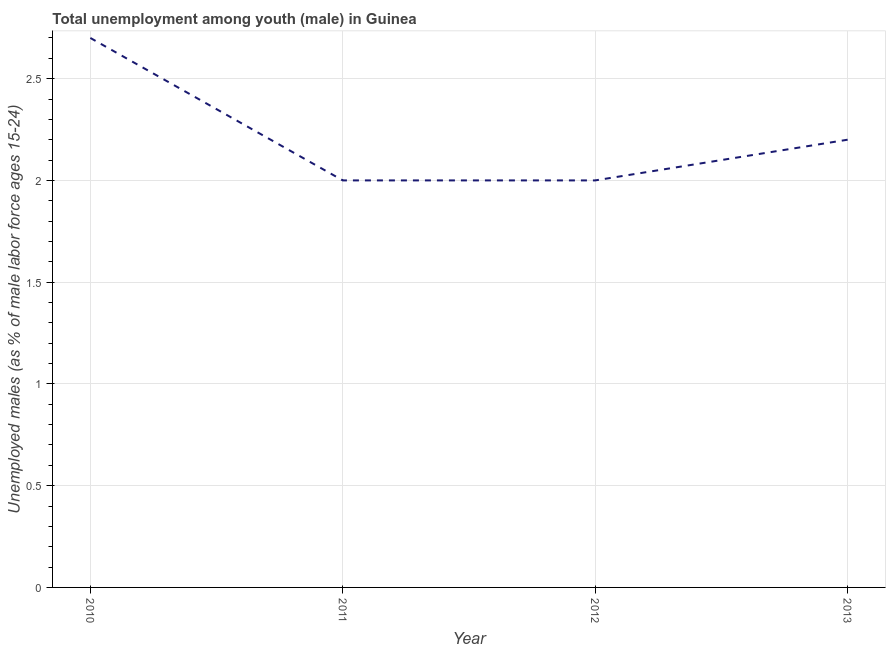What is the unemployed male youth population in 2011?
Offer a terse response. 2. Across all years, what is the maximum unemployed male youth population?
Provide a succinct answer. 2.7. In which year was the unemployed male youth population minimum?
Keep it short and to the point. 2011. What is the sum of the unemployed male youth population?
Give a very brief answer. 8.9. What is the difference between the unemployed male youth population in 2012 and 2013?
Your response must be concise. -0.2. What is the average unemployed male youth population per year?
Give a very brief answer. 2.23. What is the median unemployed male youth population?
Give a very brief answer. 2.1. Do a majority of the years between 2010 and 2012 (inclusive) have unemployed male youth population greater than 2.2 %?
Provide a succinct answer. No. What is the ratio of the unemployed male youth population in 2010 to that in 2012?
Offer a terse response. 1.35. Is the sum of the unemployed male youth population in 2011 and 2012 greater than the maximum unemployed male youth population across all years?
Make the answer very short. Yes. What is the difference between the highest and the lowest unemployed male youth population?
Ensure brevity in your answer.  0.7. In how many years, is the unemployed male youth population greater than the average unemployed male youth population taken over all years?
Ensure brevity in your answer.  1. How many lines are there?
Keep it short and to the point. 1. What is the difference between two consecutive major ticks on the Y-axis?
Ensure brevity in your answer.  0.5. Does the graph contain grids?
Offer a terse response. Yes. What is the title of the graph?
Make the answer very short. Total unemployment among youth (male) in Guinea. What is the label or title of the Y-axis?
Offer a very short reply. Unemployed males (as % of male labor force ages 15-24). What is the Unemployed males (as % of male labor force ages 15-24) in 2010?
Offer a terse response. 2.7. What is the Unemployed males (as % of male labor force ages 15-24) in 2011?
Keep it short and to the point. 2. What is the Unemployed males (as % of male labor force ages 15-24) in 2012?
Offer a very short reply. 2. What is the Unemployed males (as % of male labor force ages 15-24) of 2013?
Provide a succinct answer. 2.2. What is the difference between the Unemployed males (as % of male labor force ages 15-24) in 2010 and 2011?
Provide a short and direct response. 0.7. What is the difference between the Unemployed males (as % of male labor force ages 15-24) in 2010 and 2012?
Ensure brevity in your answer.  0.7. What is the difference between the Unemployed males (as % of male labor force ages 15-24) in 2011 and 2012?
Provide a succinct answer. 0. What is the ratio of the Unemployed males (as % of male labor force ages 15-24) in 2010 to that in 2011?
Give a very brief answer. 1.35. What is the ratio of the Unemployed males (as % of male labor force ages 15-24) in 2010 to that in 2012?
Ensure brevity in your answer.  1.35. What is the ratio of the Unemployed males (as % of male labor force ages 15-24) in 2010 to that in 2013?
Keep it short and to the point. 1.23. What is the ratio of the Unemployed males (as % of male labor force ages 15-24) in 2011 to that in 2013?
Your response must be concise. 0.91. What is the ratio of the Unemployed males (as % of male labor force ages 15-24) in 2012 to that in 2013?
Make the answer very short. 0.91. 